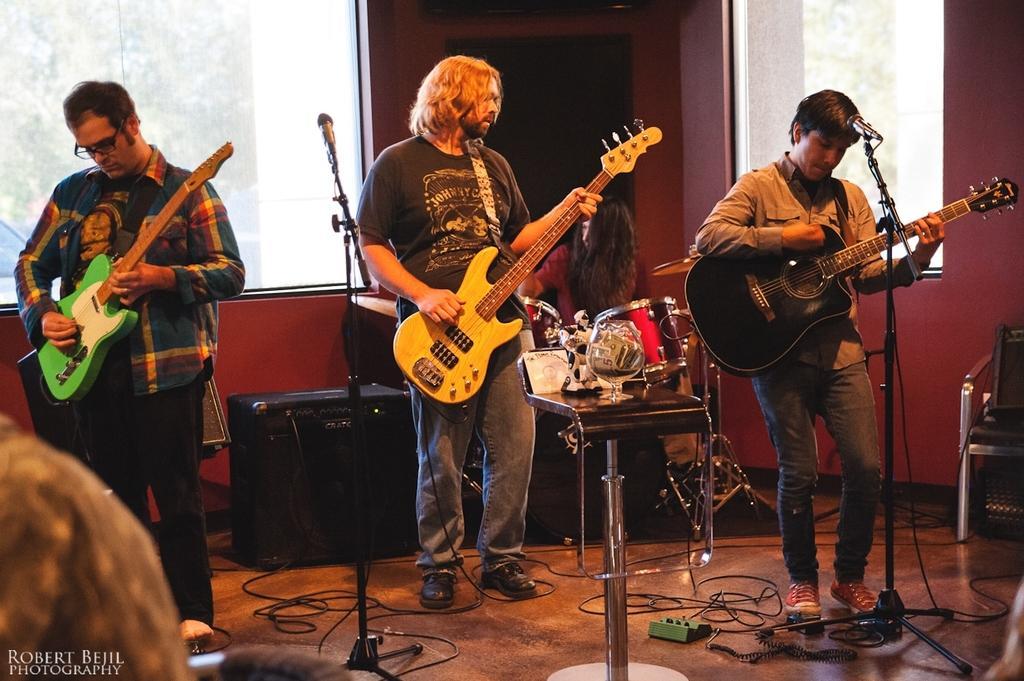Please provide a concise description of this image. It is a closed room where people are playing guitars. Coming to the left corner of the picture the person playing a green colour guitar and wearing a shirt and on right side of the picture a person playing a guitar which is in black colour and the person in the middle playing a guitar which is in yellow colour he is wearing a t-shirt, behind him there is a person sitting and playing the drums and behind him there is a wall and windows and on the floor there are wires are placed and behind them there are speakers and coming to the right corner of the picture there is a chair and outside of the room there is a vehicle on the road. 